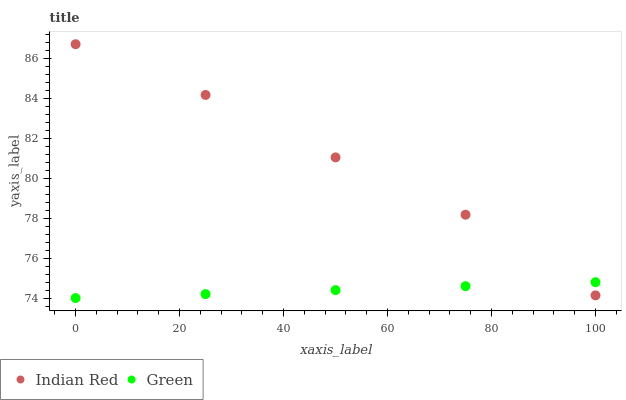Does Green have the minimum area under the curve?
Answer yes or no. Yes. Does Indian Red have the maximum area under the curve?
Answer yes or no. Yes. Does Indian Red have the minimum area under the curve?
Answer yes or no. No. Is Green the smoothest?
Answer yes or no. Yes. Is Indian Red the roughest?
Answer yes or no. Yes. Is Indian Red the smoothest?
Answer yes or no. No. Does Green have the lowest value?
Answer yes or no. Yes. Does Indian Red have the lowest value?
Answer yes or no. No. Does Indian Red have the highest value?
Answer yes or no. Yes. Does Indian Red intersect Green?
Answer yes or no. Yes. Is Indian Red less than Green?
Answer yes or no. No. Is Indian Red greater than Green?
Answer yes or no. No. 